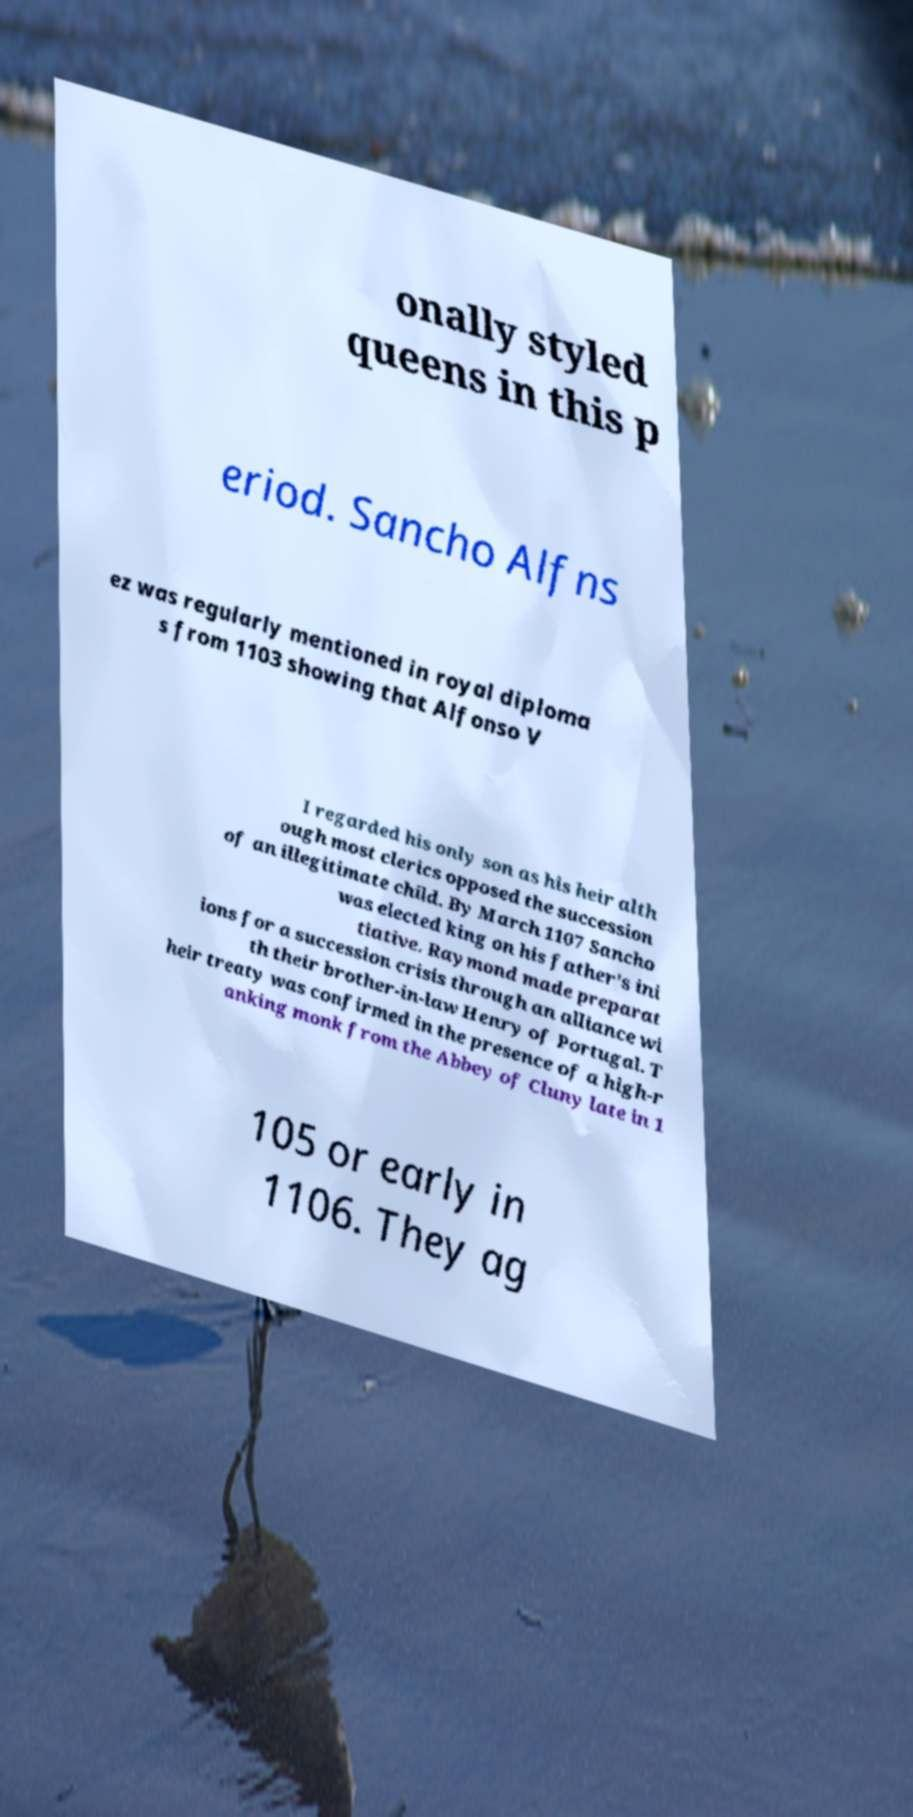Can you accurately transcribe the text from the provided image for me? onally styled queens in this p eriod. Sancho Alfns ez was regularly mentioned in royal diploma s from 1103 showing that Alfonso V I regarded his only son as his heir alth ough most clerics opposed the succession of an illegitimate child. By March 1107 Sancho was elected king on his father's ini tiative. Raymond made preparat ions for a succession crisis through an alliance wi th their brother-in-law Henry of Portugal. T heir treaty was confirmed in the presence of a high-r anking monk from the Abbey of Cluny late in 1 105 or early in 1106. They ag 